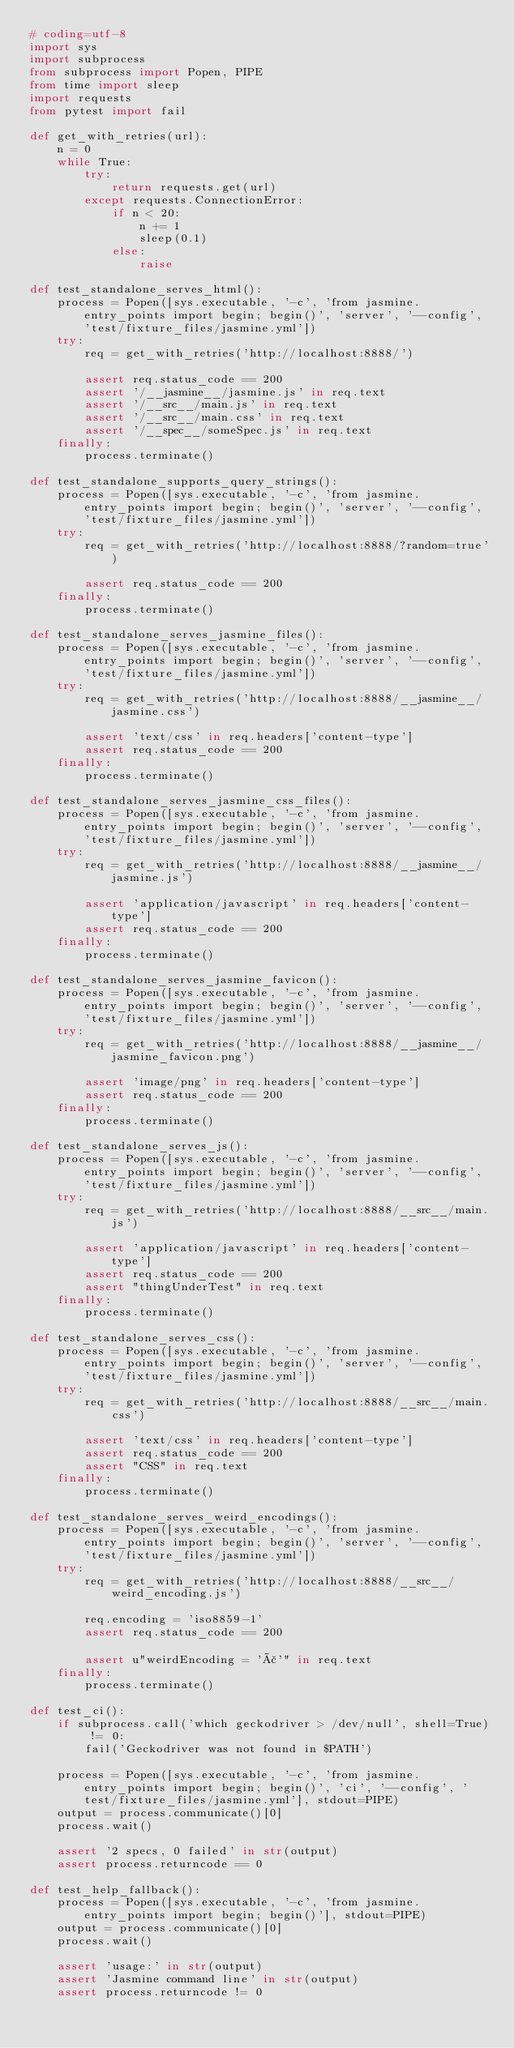Convert code to text. <code><loc_0><loc_0><loc_500><loc_500><_Python_># coding=utf-8
import sys
import subprocess
from subprocess import Popen, PIPE
from time import sleep
import requests
from pytest import fail

def get_with_retries(url):
    n = 0
    while True:
        try:
            return requests.get(url)
        except requests.ConnectionError:
            if n < 20:
                n += 1
                sleep(0.1)
            else:
                raise

def test_standalone_serves_html():
    process = Popen([sys.executable, '-c', 'from jasmine.entry_points import begin; begin()', 'server', '--config', 'test/fixture_files/jasmine.yml'])
    try:
        req = get_with_retries('http://localhost:8888/')

        assert req.status_code == 200
        assert '/__jasmine__/jasmine.js' in req.text
        assert '/__src__/main.js' in req.text
        assert '/__src__/main.css' in req.text
        assert '/__spec__/someSpec.js' in req.text
    finally:
        process.terminate()

def test_standalone_supports_query_strings():
    process = Popen([sys.executable, '-c', 'from jasmine.entry_points import begin; begin()', 'server', '--config', 'test/fixture_files/jasmine.yml'])
    try:
        req = get_with_retries('http://localhost:8888/?random=true')

        assert req.status_code == 200
    finally:
        process.terminate()

def test_standalone_serves_jasmine_files():
    process = Popen([sys.executable, '-c', 'from jasmine.entry_points import begin; begin()', 'server', '--config', 'test/fixture_files/jasmine.yml'])
    try:
        req = get_with_retries('http://localhost:8888/__jasmine__/jasmine.css')

        assert 'text/css' in req.headers['content-type']
        assert req.status_code == 200
    finally:
        process.terminate()

def test_standalone_serves_jasmine_css_files():
    process = Popen([sys.executable, '-c', 'from jasmine.entry_points import begin; begin()', 'server', '--config', 'test/fixture_files/jasmine.yml'])
    try:
        req = get_with_retries('http://localhost:8888/__jasmine__/jasmine.js')

        assert 'application/javascript' in req.headers['content-type']
        assert req.status_code == 200
    finally:
        process.terminate()

def test_standalone_serves_jasmine_favicon():
    process = Popen([sys.executable, '-c', 'from jasmine.entry_points import begin; begin()', 'server', '--config', 'test/fixture_files/jasmine.yml'])
    try:
        req = get_with_retries('http://localhost:8888/__jasmine__/jasmine_favicon.png')

        assert 'image/png' in req.headers['content-type']
        assert req.status_code == 200
    finally:
        process.terminate()

def test_standalone_serves_js():
    process = Popen([sys.executable, '-c', 'from jasmine.entry_points import begin; begin()', 'server', '--config', 'test/fixture_files/jasmine.yml'])
    try:
        req = get_with_retries('http://localhost:8888/__src__/main.js')

        assert 'application/javascript' in req.headers['content-type']
        assert req.status_code == 200
        assert "thingUnderTest" in req.text
    finally:
        process.terminate()

def test_standalone_serves_css():
    process = Popen([sys.executable, '-c', 'from jasmine.entry_points import begin; begin()', 'server', '--config', 'test/fixture_files/jasmine.yml'])
    try:
        req = get_with_retries('http://localhost:8888/__src__/main.css')

        assert 'text/css' in req.headers['content-type']
        assert req.status_code == 200
        assert "CSS" in req.text
    finally:
        process.terminate()

def test_standalone_serves_weird_encodings():
    process = Popen([sys.executable, '-c', 'from jasmine.entry_points import begin; begin()', 'server', '--config', 'test/fixture_files/jasmine.yml'])
    try:
        req = get_with_retries('http://localhost:8888/__src__/weird_encoding.js')

        req.encoding = 'iso8859-1'
        assert req.status_code == 200

        assert u"weirdEncoding = 'ã'" in req.text
    finally:
        process.terminate()

def test_ci():
    if subprocess.call('which geckodriver > /dev/null', shell=True) != 0:
        fail('Geckodriver was not found in $PATH')

    process = Popen([sys.executable, '-c', 'from jasmine.entry_points import begin; begin()', 'ci', '--config', 'test/fixture_files/jasmine.yml'], stdout=PIPE)
    output = process.communicate()[0]
    process.wait()

    assert '2 specs, 0 failed' in str(output)
    assert process.returncode == 0

def test_help_fallback():
    process = Popen([sys.executable, '-c', 'from jasmine.entry_points import begin; begin()'], stdout=PIPE)
    output = process.communicate()[0]
    process.wait()

    assert 'usage:' in str(output)
    assert 'Jasmine command line' in str(output)
    assert process.returncode != 0
</code> 